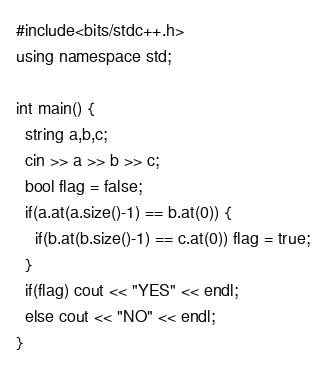<code> <loc_0><loc_0><loc_500><loc_500><_C++_>#include<bits/stdc++.h>
using namespace std;

int main() {
  string a,b,c;
  cin >> a >> b >> c;
  bool flag = false;
  if(a.at(a.size()-1) == b.at(0)) {
    if(b.at(b.size()-1) == c.at(0)) flag = true;
  }
  if(flag) cout << "YES" << endl;
  else cout << "NO" << endl;
}</code> 